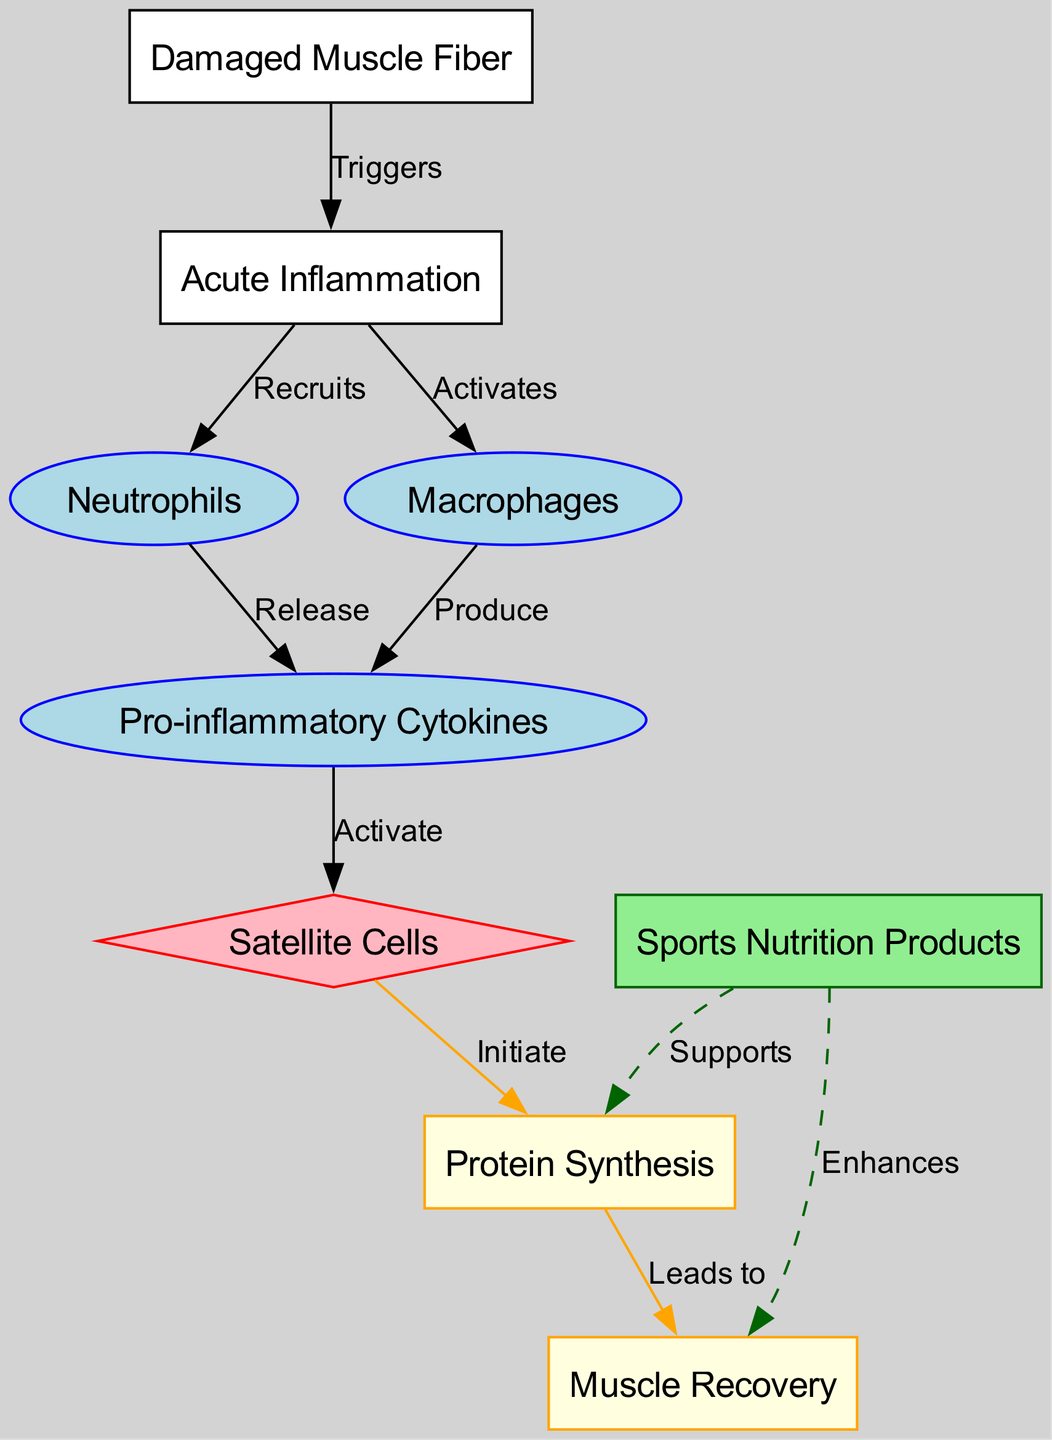What is the starting point of the recovery process? The recovery process starts with the "Damaged Muscle Fiber" node, which indicates the initial trigger for inflammation following resistance training.
Answer: Damaged Muscle Fiber How many types of cells are involved in the inflammatory response? The diagram features three types of cells involved in the inflammatory response: Neutrophils, Macrophages, and Satellite Cells.
Answer: Three What do macrophages produce during the inflammatory response? The diagram clearly shows that Macrophages produce Pro-inflammatory Cytokines during the inflammatory response, as indicated by the edge that connects these two nodes.
Answer: Pro-inflammatory Cytokines What role do cytokines play in the recovery process? Cytokines activate Satellite Cells, which is essential in the recovery process as they initiate protein synthesis necessary for muscle repair.
Answer: Activate Satellite Cells How does sports nutrition contribute to muscle recovery? The diagram illustrates that Sports Nutrition Products support protein synthesis and enhance muscle recovery, making nutrition a critical factor for effective recovery.
Answer: Supports protein synthesis, Enhances muscle recovery What triggers the acute inflammation according to the diagram? The diagram indicates that damaged muscle fibers trigger acute inflammation, initiating the cascade of the recovery process.
Answer: Damaged Muscle Fiber Which process is directly initiated by satellite cells? The diagram shows that Satellite Cells directly initiate Protein Synthesis, which is crucial for muscle recovery following resistance training.
Answer: Protein Synthesis How do neutrophils contribute to cytokine release? The diagram specifies that Neutrophils release Pro-inflammatory Cytokines during the inflammatory response, linking these two nodes in the recovery process.
Answer: Release Pro-inflammatory Cytokines What is the final outcome indicated in the recovery process? The final outcome indicated in the diagram is Muscle Recovery, which results from effective protein synthesis following the inflammatory response.
Answer: Muscle Recovery 